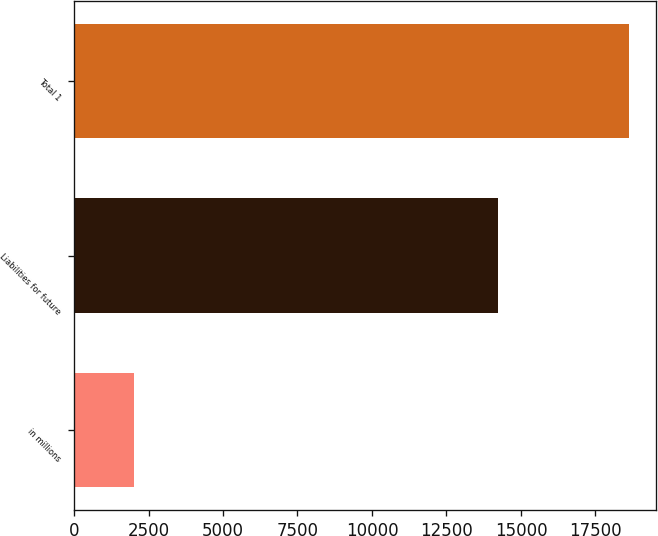Convert chart. <chart><loc_0><loc_0><loc_500><loc_500><bar_chart><fcel>in millions<fcel>Liabilities for future<fcel>Total 1<nl><fcel>2011<fcel>14213<fcel>18614<nl></chart> 